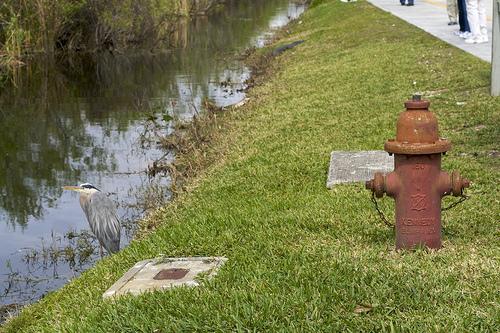About how far is the hydrant from the river?
Quick response, please. 5 feet. What color is the hydrant?
Quick response, please. Red. Does the water flow?
Answer briefly. No. Is this fire hydrant busted?
Be succinct. No. Is the hydrant old or new?
Give a very brief answer. Old. Where is the bird?
Answer briefly. In water. 